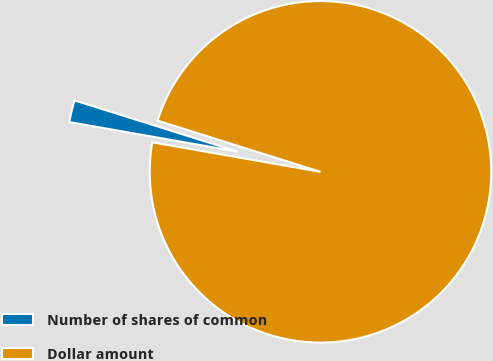Convert chart to OTSL. <chart><loc_0><loc_0><loc_500><loc_500><pie_chart><fcel>Number of shares of common<fcel>Dollar amount<nl><fcel>2.08%<fcel>97.92%<nl></chart> 